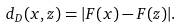<formula> <loc_0><loc_0><loc_500><loc_500>d _ { D } ( x , z ) = | F ( x ) - F ( z ) | .</formula> 